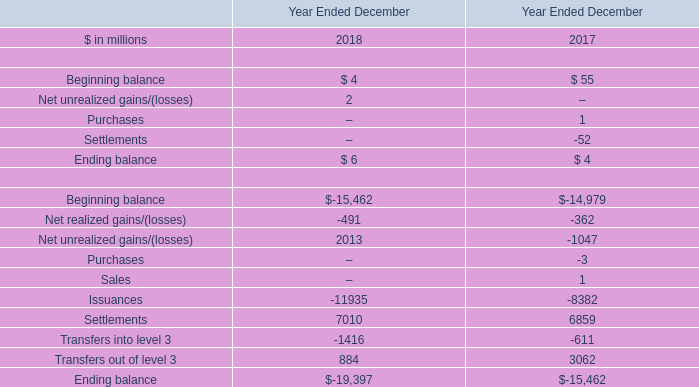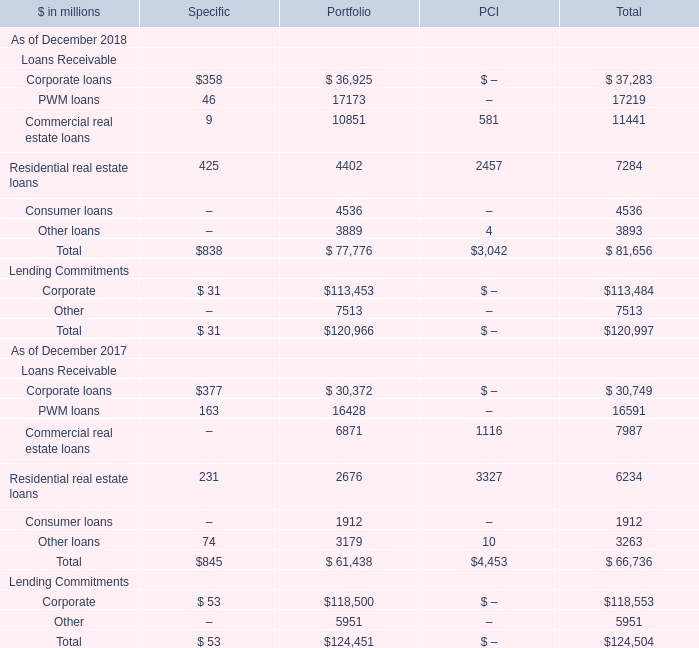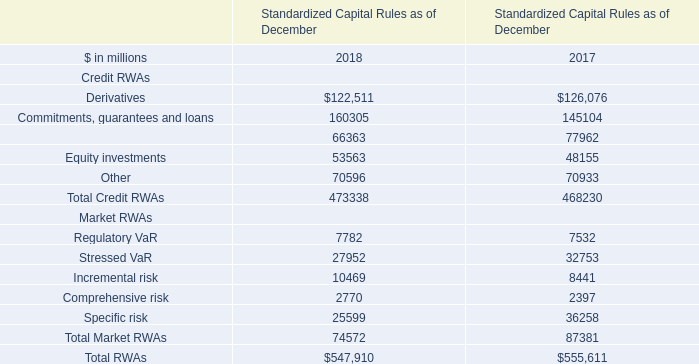What is the sum of Loans Receivable in the range of 0 and 40000 in 2018 for Total? (in million) 
Computations: (((((37283 + 17219) + 11441) + 7284) + 4536) + 3893)
Answer: 81656.0. 